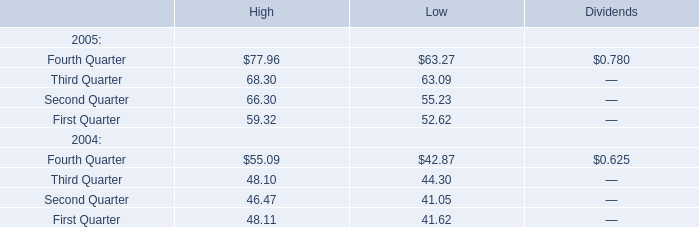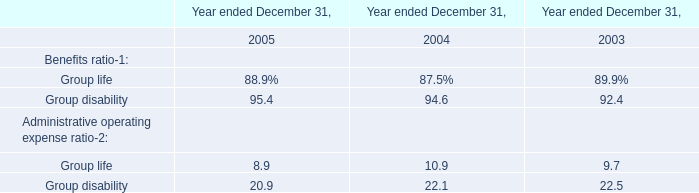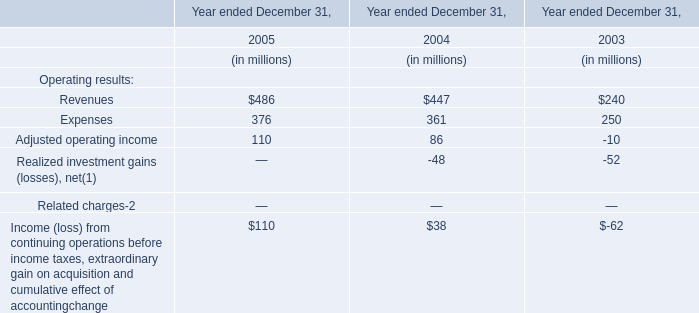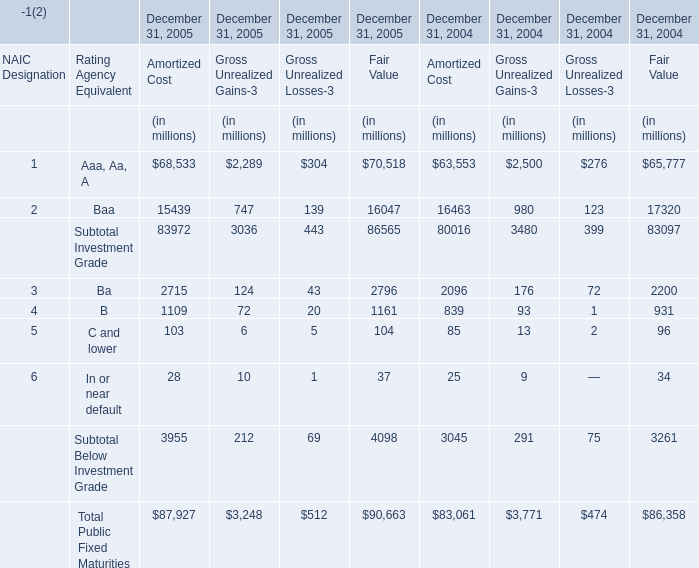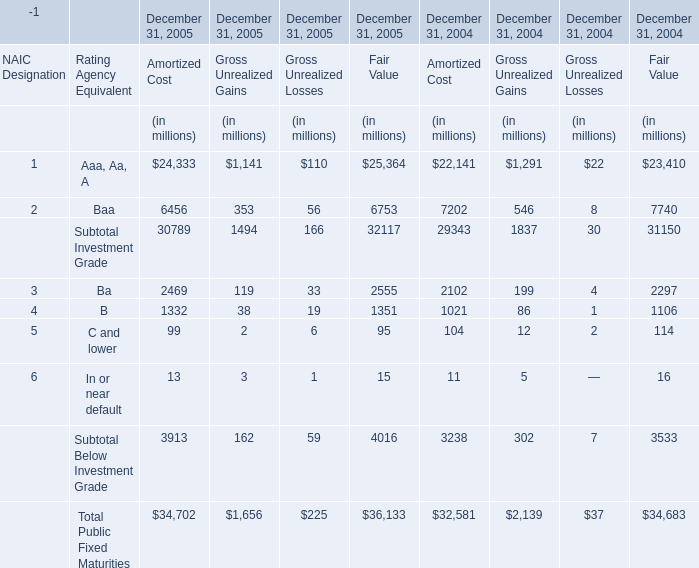How many Amortized Cost exceed the average of Amortized Cost in 2005 for December 31, 2005? 
Answer: 2. 